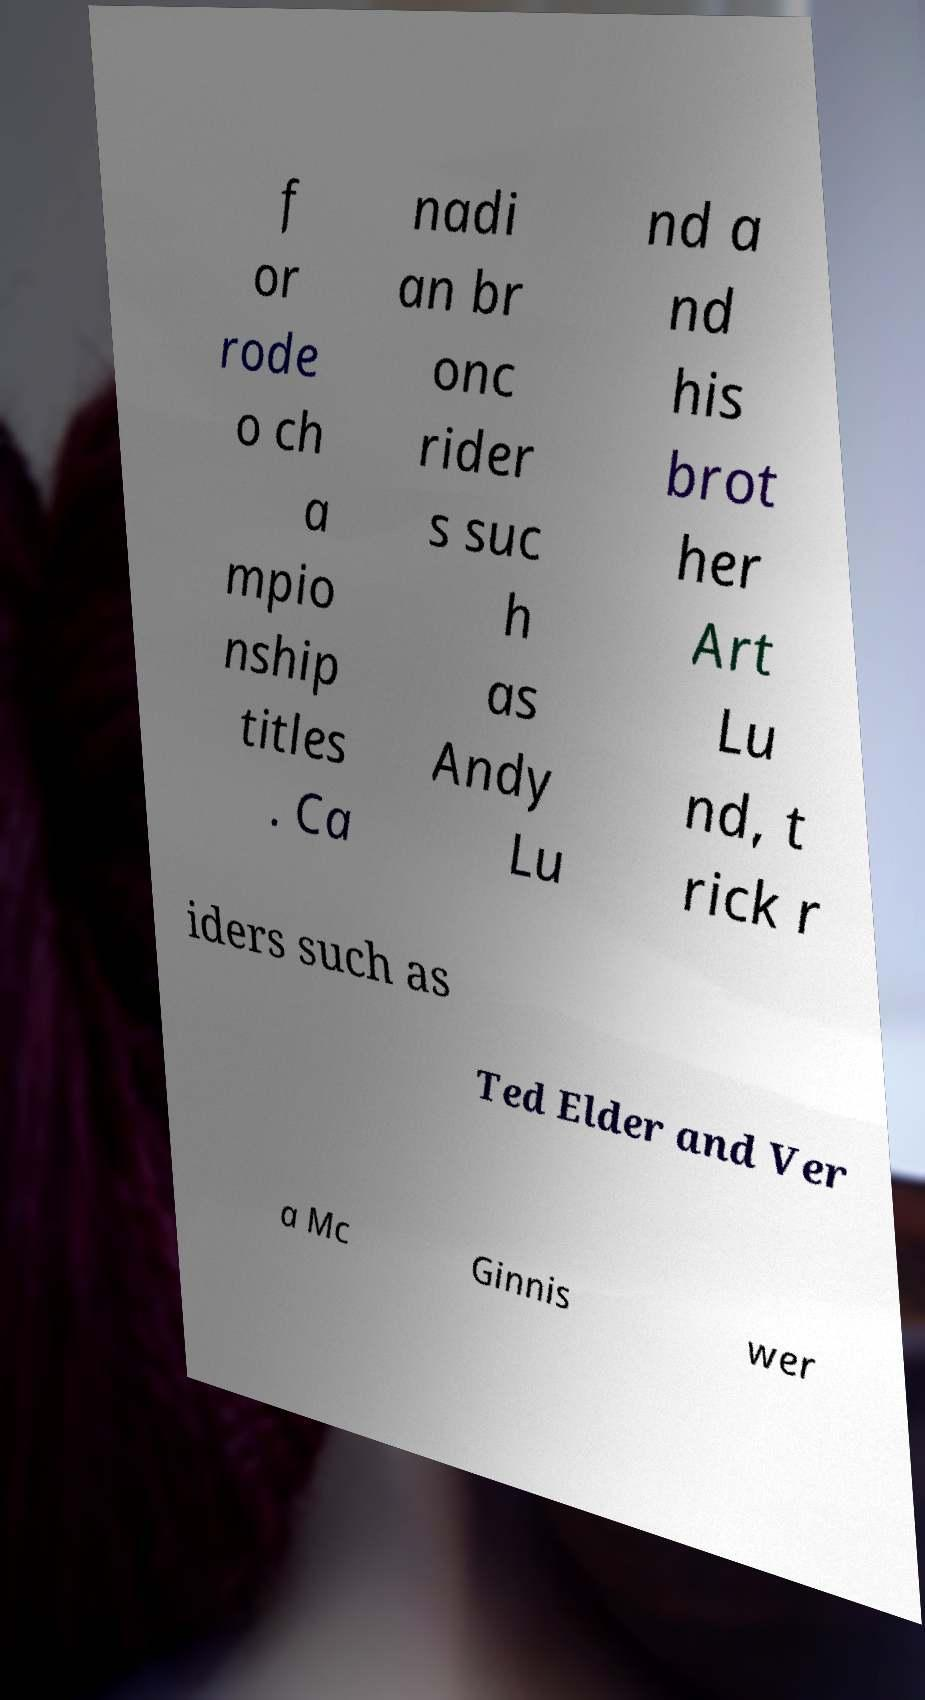Could you extract and type out the text from this image? f or rode o ch a mpio nship titles . Ca nadi an br onc rider s suc h as Andy Lu nd a nd his brot her Art Lu nd, t rick r iders such as Ted Elder and Ver a Mc Ginnis wer 